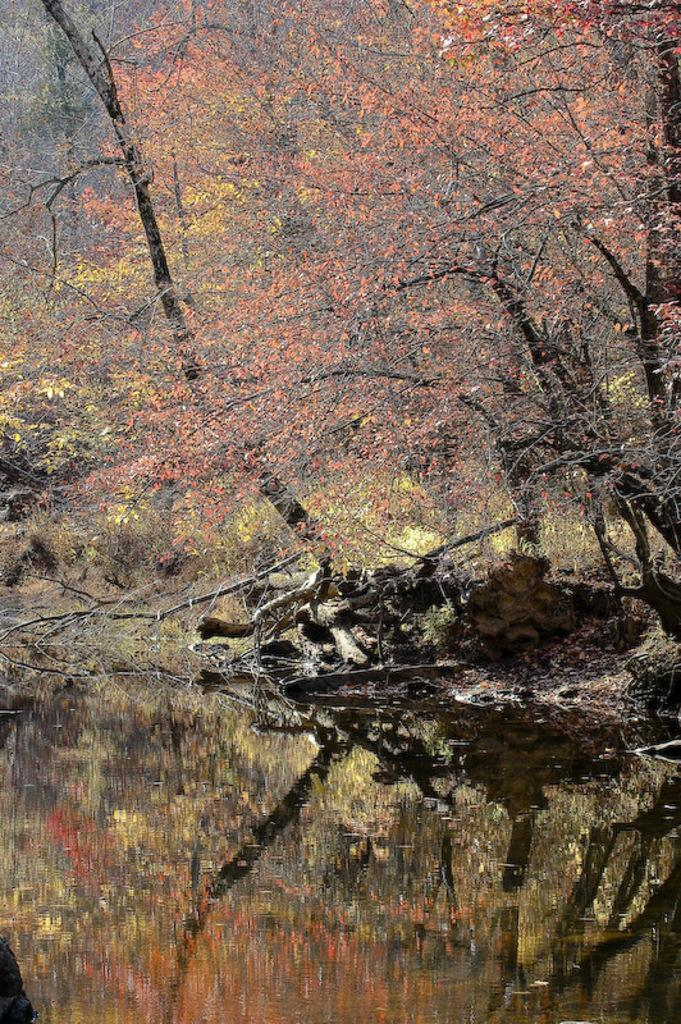What can be seen in the image? There is water visible in the image, and there are trees present as well. Can you describe the water in the image? The water is visible, but its specific characteristics are not mentioned in the provided facts. What type of vegetation is present in the image? Trees are the type of vegetation present in the image. What type of badge is being awarded in the image? There is no badge or any indication of a competition or action in the image. What type of action is being performed by the trees in the image? Trees are not capable of performing actions, as they are inanimate objects. 